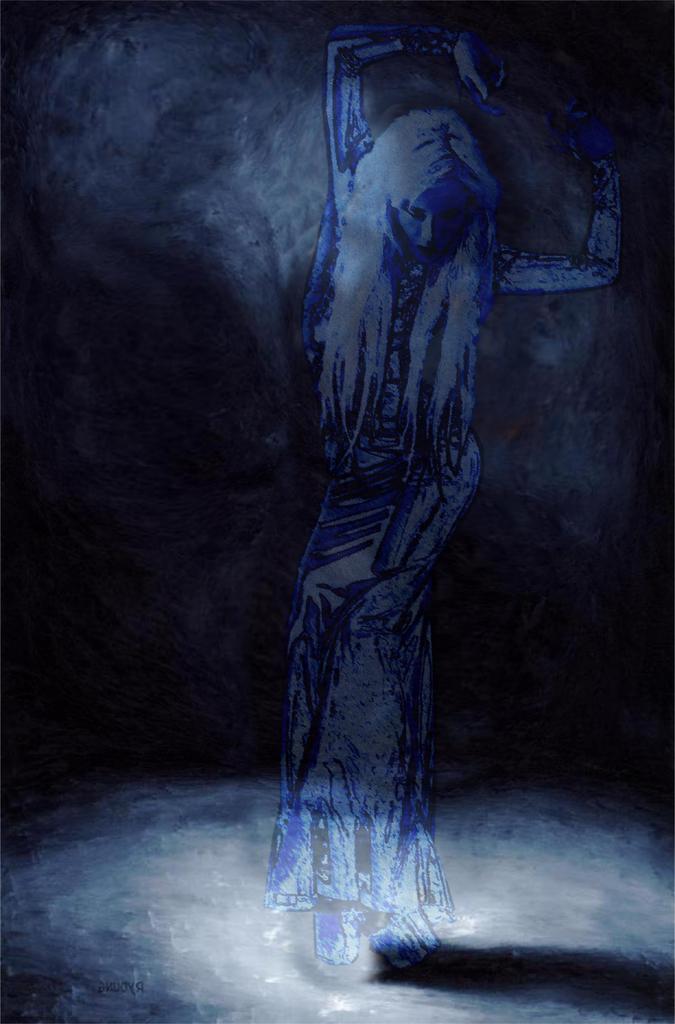In one or two sentences, can you explain what this image depicts? There is a painting in which, there is a person standing on a surface. And the background is dark in color. 